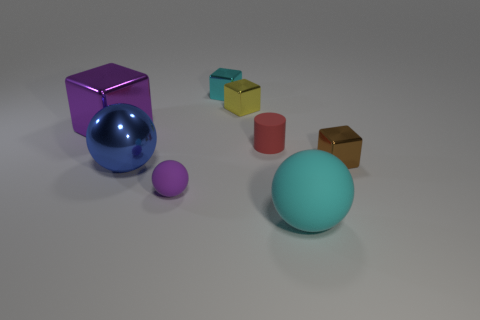Are there fewer purple rubber balls that are behind the tiny brown metal thing than small green metal blocks?
Make the answer very short. No. Is there a gray matte object of the same size as the cyan shiny block?
Offer a very short reply. No. What is the color of the small rubber cylinder?
Provide a short and direct response. Red. Is the blue shiny thing the same size as the purple metallic cube?
Your response must be concise. Yes. Are there an equal number of purple matte things behind the tiny purple rubber sphere and yellow metallic objects?
Keep it short and to the point. No. Is there a yellow metallic cube on the left side of the rubber thing that is in front of the small thing that is in front of the small brown shiny cube?
Provide a succinct answer. Yes. There is a small object that is made of the same material as the small ball; what is its color?
Your answer should be very brief. Red. There is a metallic object on the left side of the big blue object; is it the same color as the tiny ball?
Your response must be concise. Yes. There is a purple thing on the left side of the ball on the left side of the purple thing that is in front of the blue ball; how big is it?
Offer a terse response. Large. There is a blue object that is the same size as the cyan rubber ball; what is its shape?
Offer a very short reply. Sphere. 